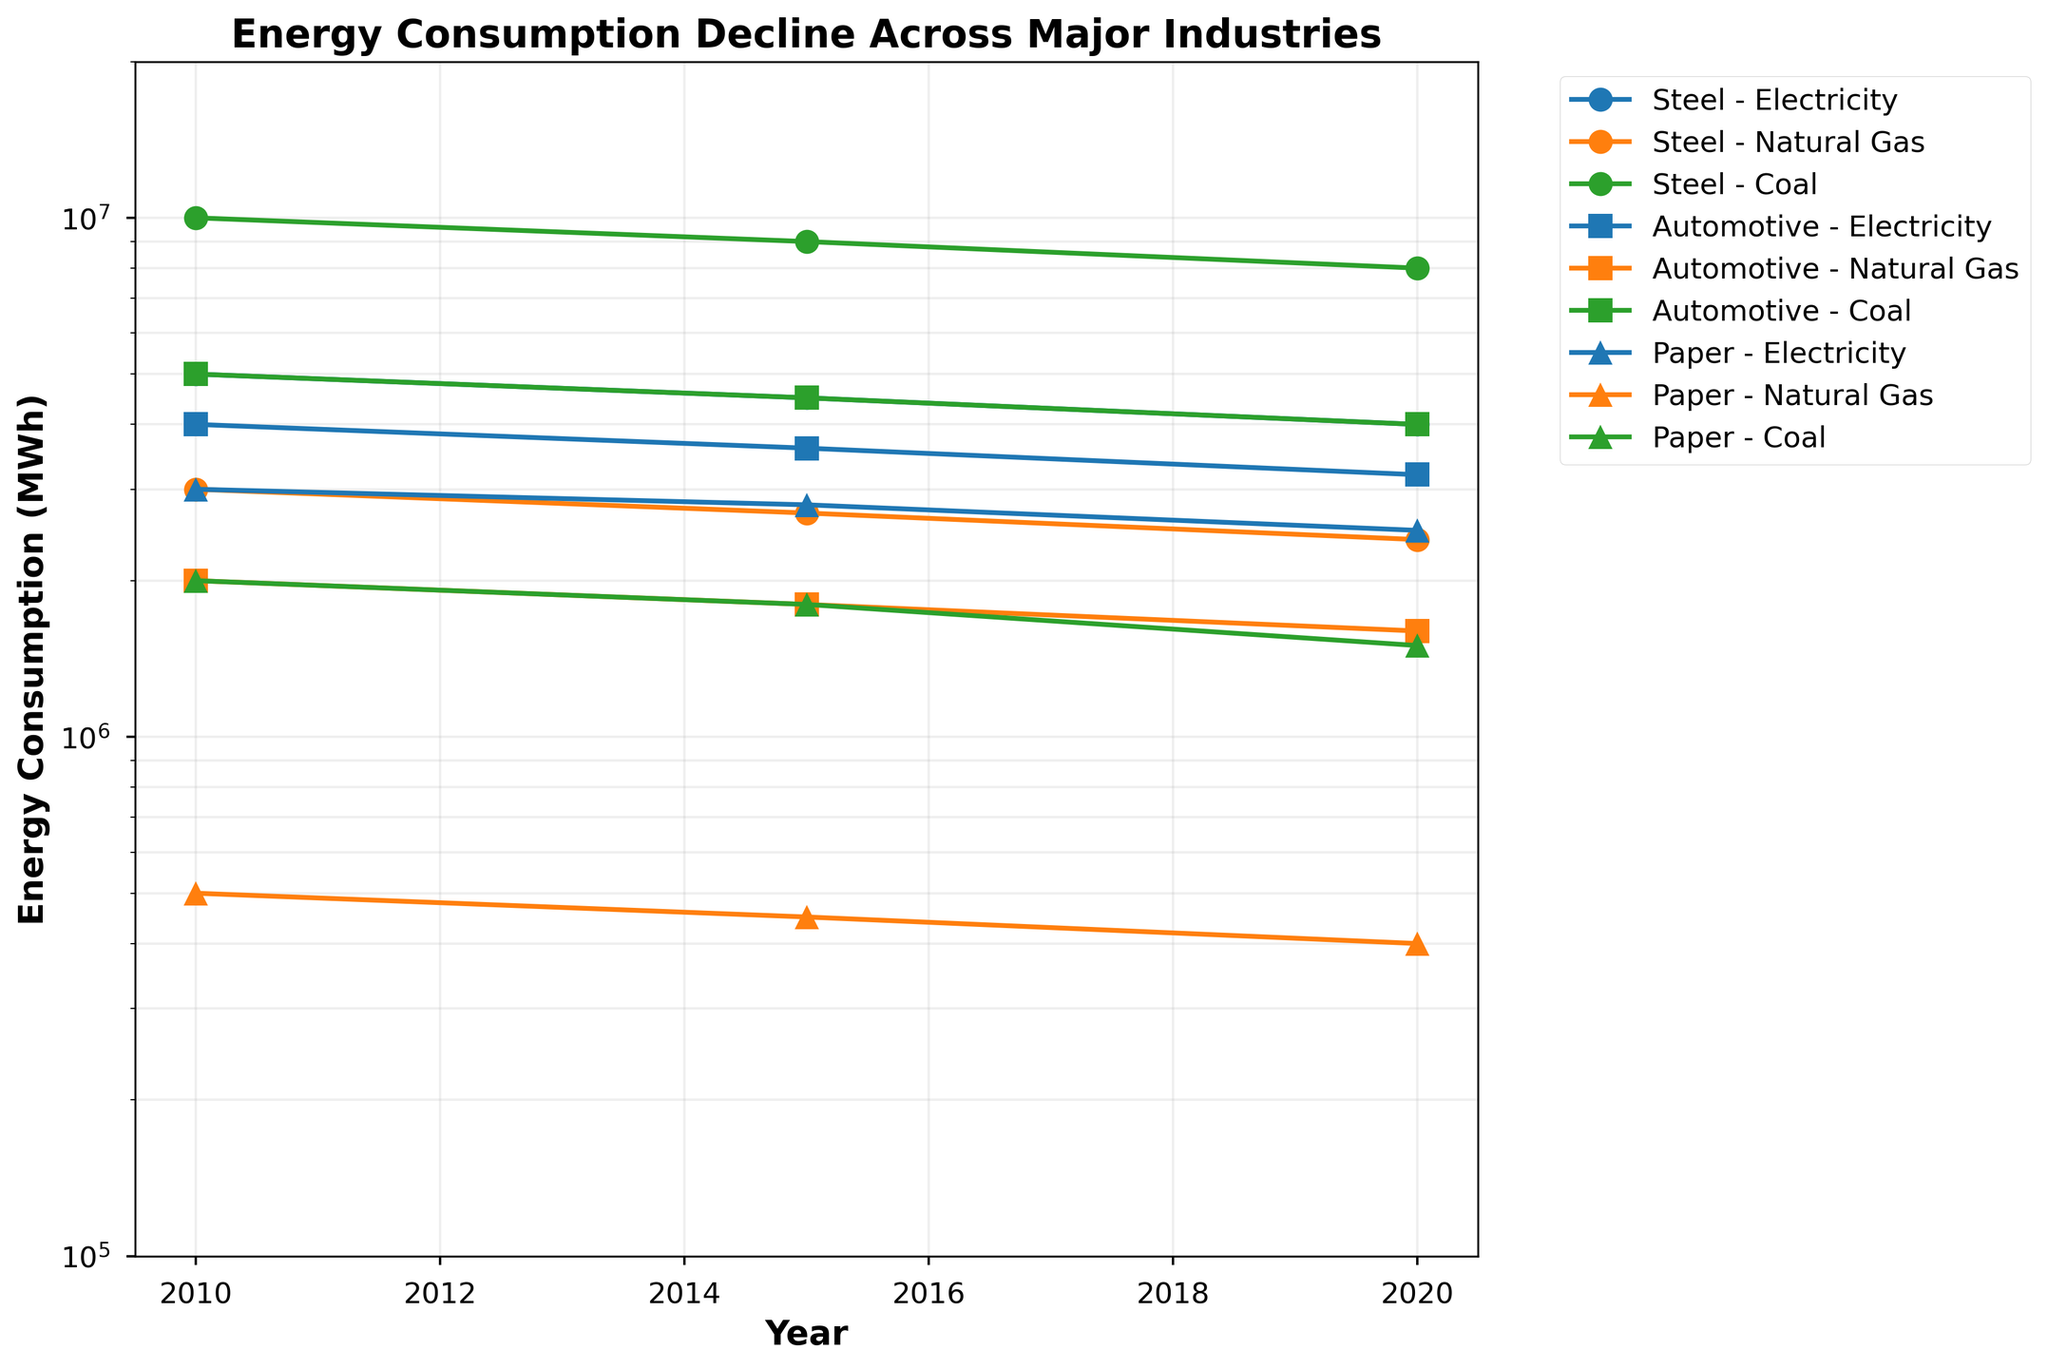What is the title of the plot? The title of the plot is typically displayed at the top of the figure. It gives an overview of what the plot is about. Here, the title is "Energy Consumption Decline Across Major Industries".
Answer: Energy Consumption Decline Across Major Industries How many years of data are shown in the plot? By observing the x-axis, we can see that the data points are marked at three different years: 2010, 2015, and 2020.
Answer: 3 Which industry has the highest energy consumption from coal in 2010? By looking at the legend and the data points marked with coal consumption on the y-axis at the year 2010, Steel industry has the highest energy consumption with a value of 10,000,000 MWh.
Answer: Steel What is the color representation for Natural Gas on the plot? The colors representing different energy types can be identified by looking at the legend. Natural Gas is shown with a color that corresponds to the specific items mentioned in the legend. Here, it is in orange.
Answer: Orange How does the energy consumption from coal for the Steel industry change from 2010 to 2020? The energy consumption values for Steel industry using coal can be found by looking at the y-axis values at the specific years marked on the x-axis: it reduces from 10,000,000 MWh in 2010 to 8,000,000 MWh in 2020.
Answer: Decreases Compare the reduction in energy consumption from electricity between the Steel and Automotive industries from 2010 to 2020. Which one has reduced more? By observing the y-axis values at 2010 and 2020 for both industries, for the Steel industry, electricity consumption reduces from 5,000,000 to 4,000,000 MWh which is a reduction of 1,000,000 MWh. For the Automotive industry, it reduces from 4,000,000 to 3,200,000 MWh which is a reduction of 800,000 MWh. Thus, Steel industry has reduced more.
Answer: Steel What's the overall trend in energy consumption for the Paper industry using coal from 2010 to 2020? Observing the y-axis values for coal use in Paper industry over the years 2010, 2015, and 2020 shows a decline from 2,000,000 MWh to 1,500,000 MWh.
Answer: Declining How much did the energy consumption for the Paper industry using Natural Gas change between 2010 and 2015? Looking at the y-axis values for Natural Gas in the Paper industry, it changes from 500,000 MWh in 2010 to 450,000 MWh in 2015, indicating a reduction of 50,000 MWh.
Answer: Decreases by 50,000 MWh What is the range of y-axis values used in the plot? The range can be determined by looking at the minimum and maximum values noted on the y-axis. Here, it ranges from 100,000 MWh to 20,000,000 MWh.
Answer: 100,000 MWh to 20,000,000 MWh What is the effect of using a log scale on the y-axis for visual interpretation? A logarithmic scale compresses larger values and expands smaller values, allowing a clearer view of both higher and lower magnitude data within the same plot. This helps in comparing proportional relationships more effectively.
Answer: Compresses larger values 